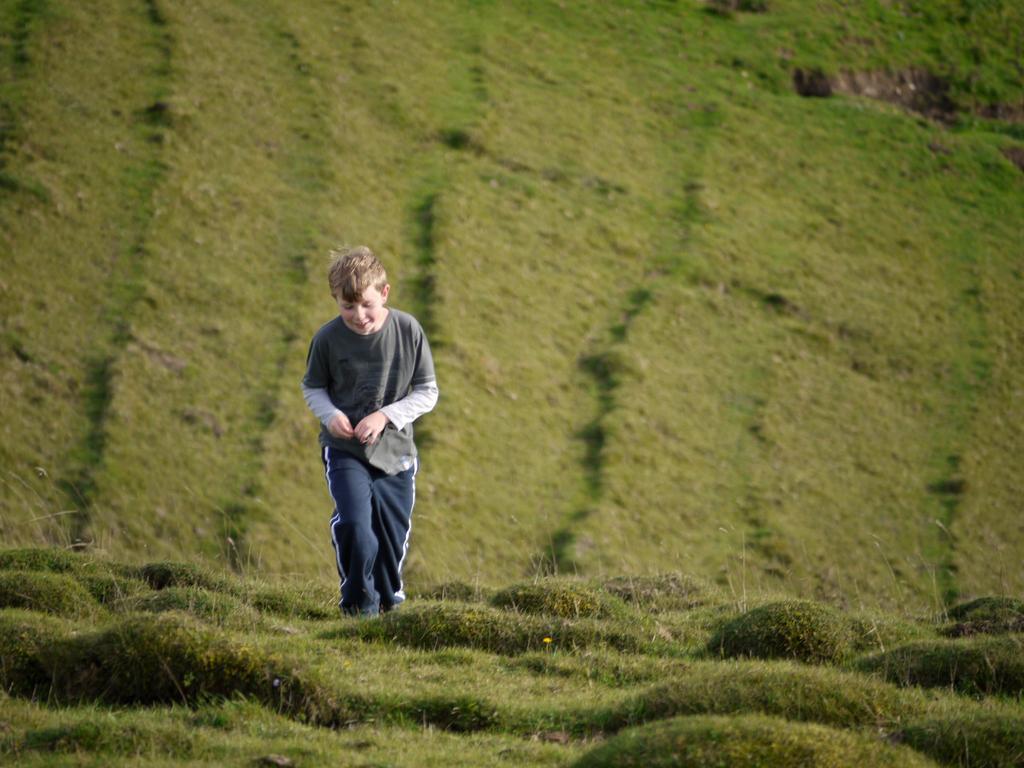In one or two sentences, can you explain what this image depicts? In this image there is a green grass at the bottom. There is a person in the foreground. And there is a green grass in the background. 